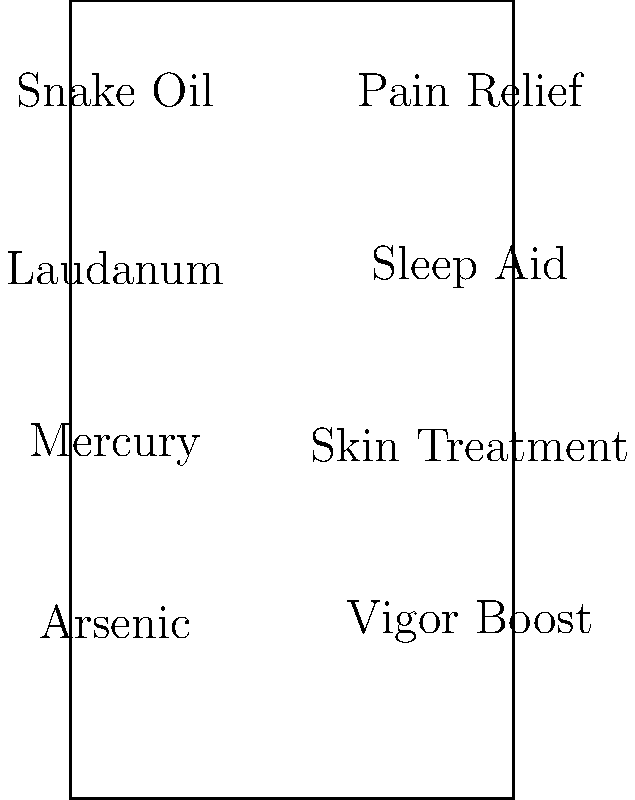Match the popular quack medicine ingredients of the 19th century to their purported benefits as commonly advertised in that era. Draw lines connecting each ingredient to its corresponding benefit. To answer this question, we need to consider the historical context of 19th-century quack medicine and the common beliefs about these ingredients:

1. Snake Oil: Despite its modern connotation as a fraudulent cure-all, snake oil was often marketed as a pain reliever. Chinese laborers introduced it to the West, where it gained popularity for treating joint pain and inflammation.

2. Laudanum: This tincture of opium was widely used as a sleep aid and pain reliever. It was easily available and commonly prescribed for various ailments, including insomnia and anxiety.

3. Mercury: Though highly toxic, mercury was used in various skin treatments, particularly for syphilis. It was believed to clear skin conditions and was a common ingredient in beauty products.

4. Arsenic: Surprisingly, arsenic was marketed as a vigor boost and general tonic. It was thought to improve complexion and was even used in weight loss treatments.

Therefore, the correct matches are:
- Snake Oil → Pain Relief
- Laudanum → Sleep Aid
- Mercury → Skin Treatment
- Arsenic → Vigor Boost
Answer: Snake Oil - Pain Relief, Laudanum - Sleep Aid, Mercury - Skin Treatment, Arsenic - Vigor Boost 